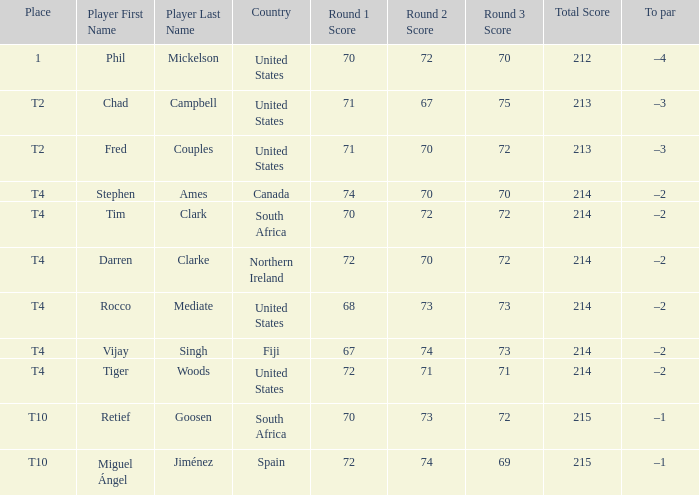What country is Chad Campbell from? United States. 